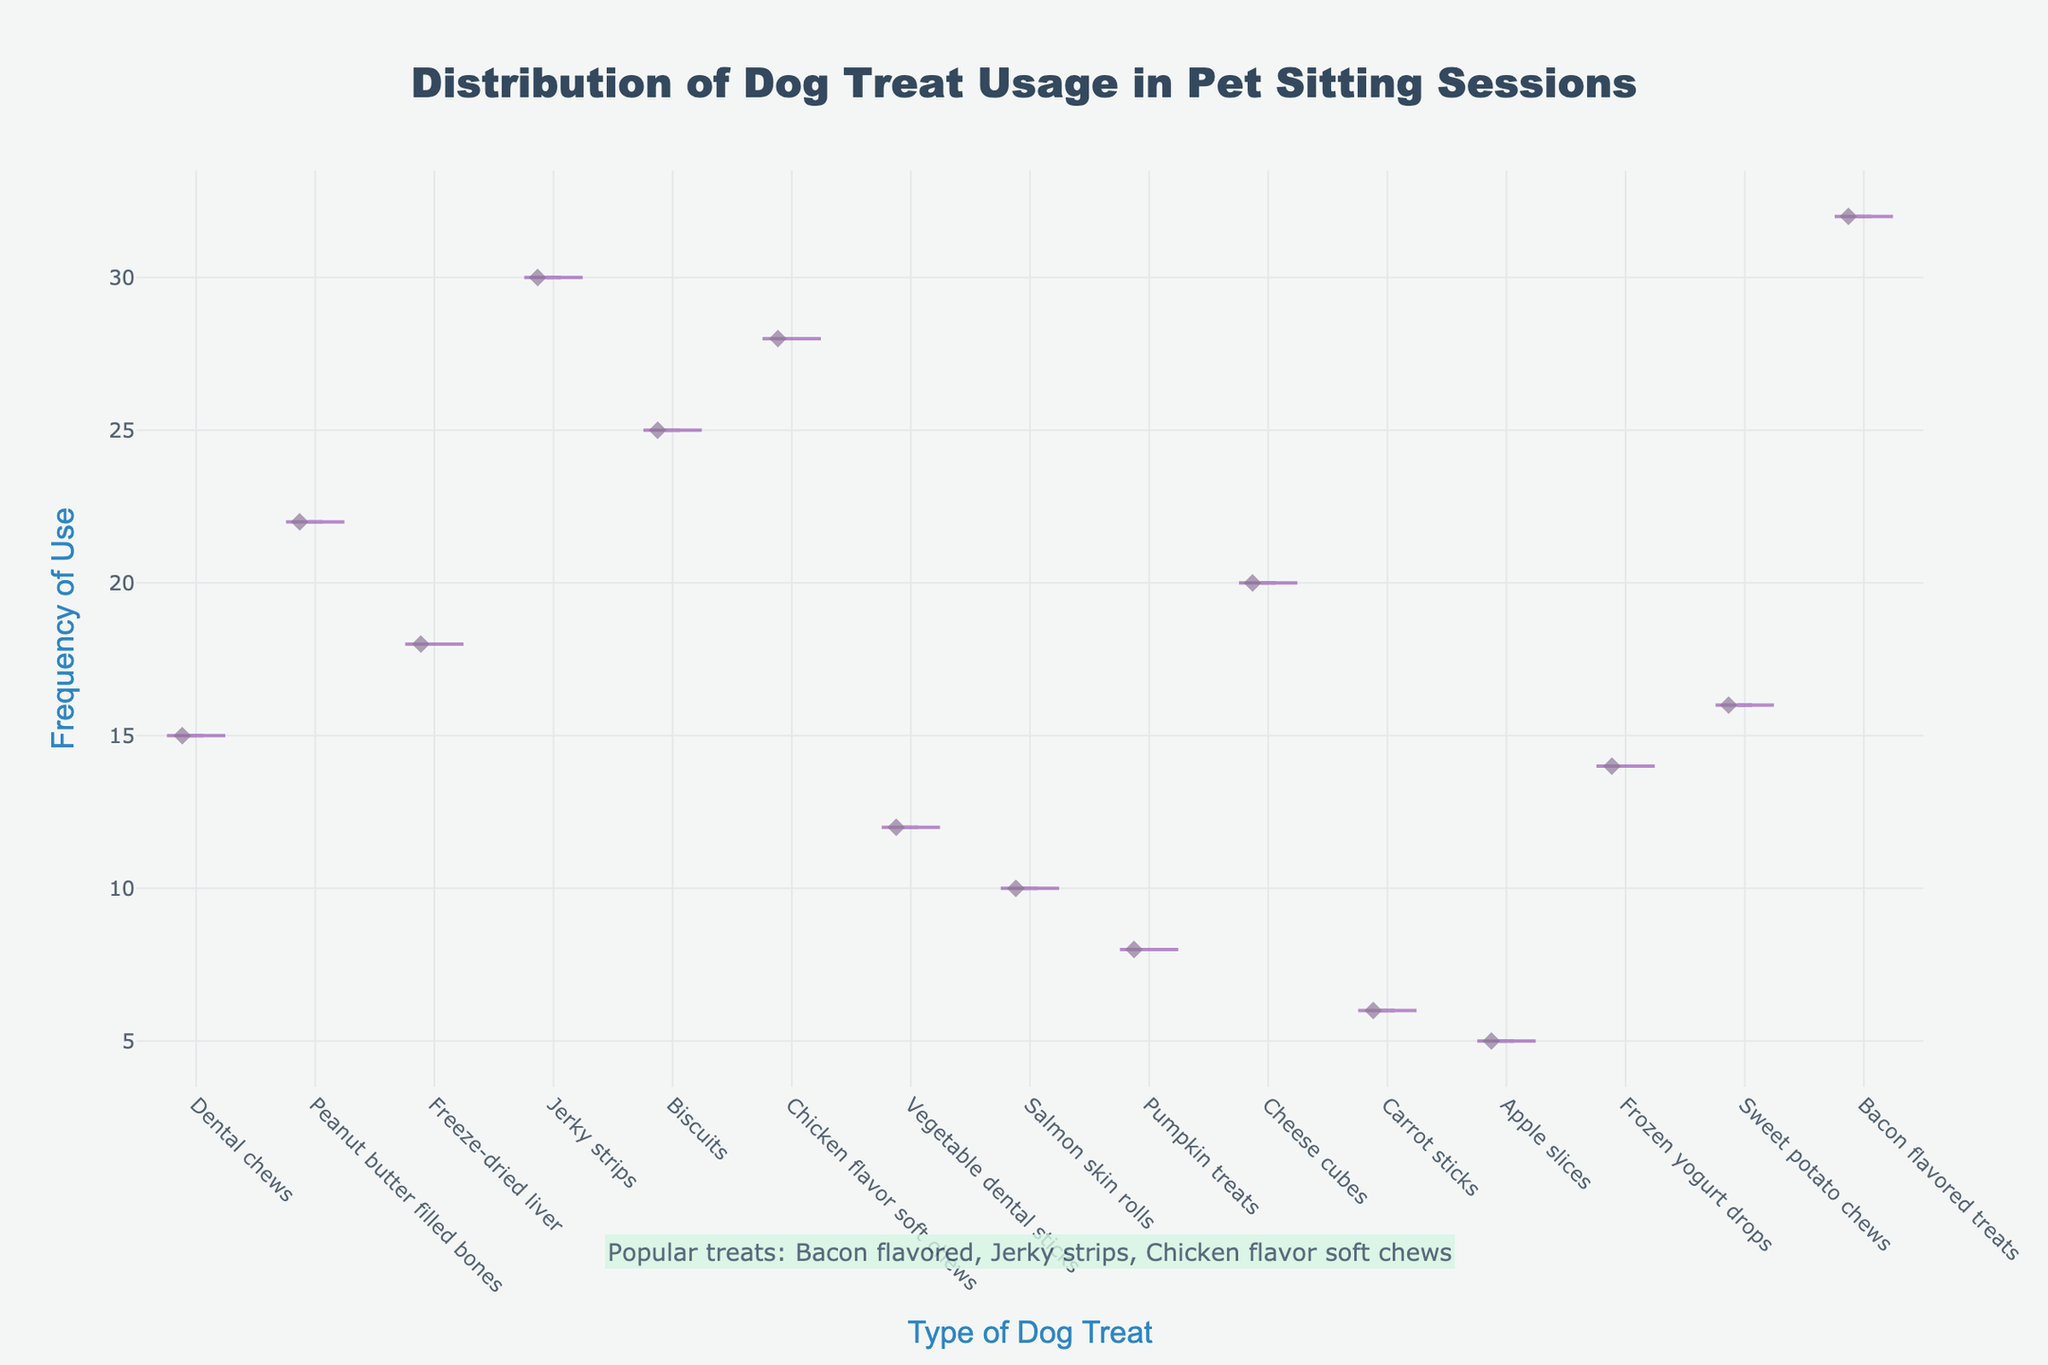What is the title of the figure? The title of the figure is displayed prominently at the top and it reads "Distribution of Dog Treat Usage in Pet Sitting Sessions".
Answer: Distribution of Dog Treat Usage in Pet Sitting Sessions Which type of dog treat has the highest frequency of use? By observing the density plot, you can see that "Bacon flavored treats" have the highest point on the frequency axis.
Answer: Bacon flavored treats How many types of dog treats have a frequency greater than 25? The treats with frequencies greater than 25, as indicated by the density plot, are "Jerky strips" (30), "Chicken flavor soft chews" (28), "Biscuits" (25), and "Bacon flavored treats" (32).
Answer: 4 What is the frequency of use for "Peanut butter filled bones"? By looking at the specific point for "Peanut butter filled bones" on the plot, you can see that its frequency is 22.
Answer: 22 Which treat types are mentioned as popular in the annotation? The annotation at the bottom of the figure highlights "Bacon flavored", "Jerky strips", and "Chicken flavor soft chews" as popular treats.
Answer: Bacon flavored, Jerky strips, Chicken flavor soft chews What is the mean frequency of "Freeze-dried liver" and "Cheese cubes"? The frequencies of "Freeze-dried liver" and "Cheese cubes" are 18 and 20 respectively. Adding these gives 38, and the average is 38/2 = 19.
Answer: 19 Which treat type has the lowest frequency of use? Observing the density plot, "Apple slices" have the lowest point on the frequency axis, indicating the lowest usage.
Answer: Apple slices Compare the frequency of "Vegetable dental sticks" and "Frozen yogurt drops". Which is higher? "Vegetable dental sticks" has a frequency of 12, whereas "Frozen yogurt drops" has a frequency of 14. Thus, "Frozen yogurt drops" is higher.
Answer: Frozen yogurt drops How does the frequency of "Sweet potato chews" compare to "Dental chews"? The frequency of "Sweet potato chews" is 16, whereas "Dental chews" have a frequency of 15. "Sweet potato chews" frequency is slightly higher than "Dental chews".
Answer: Sweet potato chews What is the frequency difference between "Jerky strips" and "Pumpkin treats"? The frequency of "Jerky strips" is 30, and "Pumpkin treats" is 8. The difference is 30 - 8 = 22.
Answer: 22 